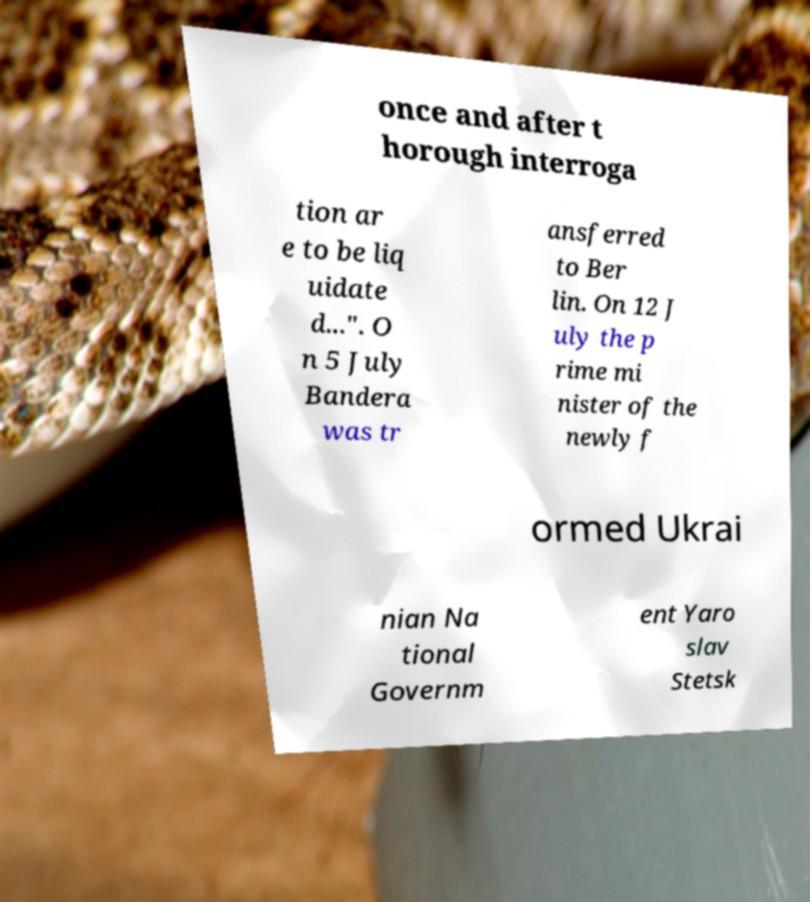Can you accurately transcribe the text from the provided image for me? once and after t horough interroga tion ar e to be liq uidate d...". O n 5 July Bandera was tr ansferred to Ber lin. On 12 J uly the p rime mi nister of the newly f ormed Ukrai nian Na tional Governm ent Yaro slav Stetsk 